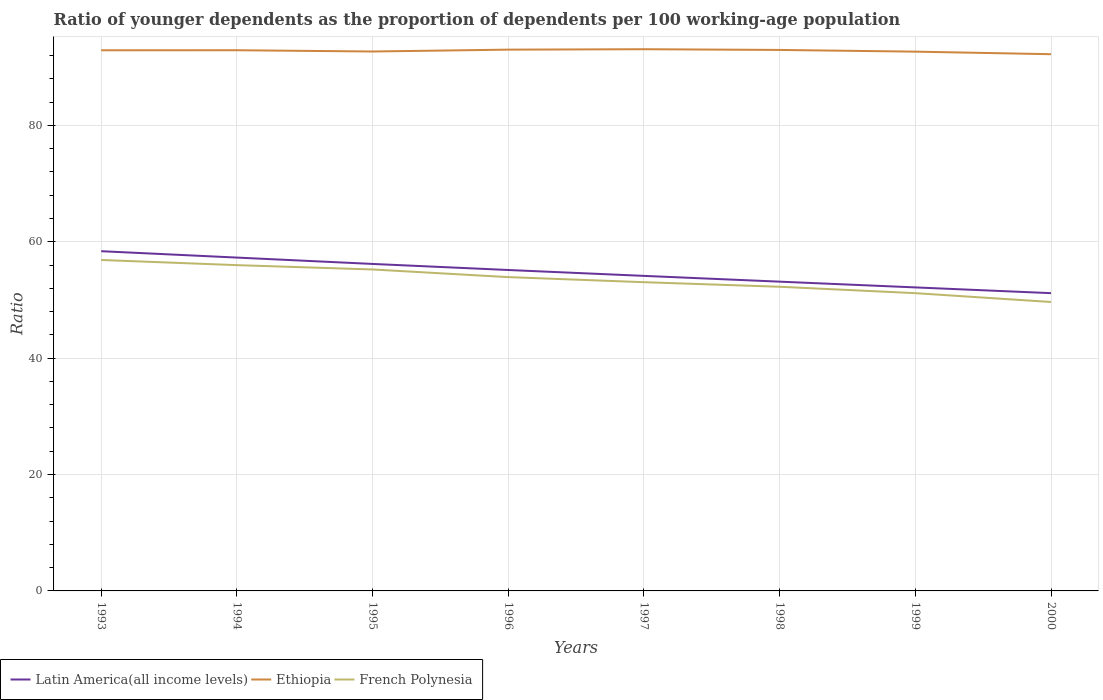Across all years, what is the maximum age dependency ratio(young) in Ethiopia?
Offer a very short reply. 92.23. In which year was the age dependency ratio(young) in French Polynesia maximum?
Provide a succinct answer. 2000. What is the total age dependency ratio(young) in French Polynesia in the graph?
Offer a very short reply. 7.22. What is the difference between the highest and the second highest age dependency ratio(young) in Ethiopia?
Your answer should be compact. 0.86. Are the values on the major ticks of Y-axis written in scientific E-notation?
Provide a succinct answer. No. Does the graph contain any zero values?
Keep it short and to the point. No. Does the graph contain grids?
Make the answer very short. Yes. How many legend labels are there?
Your answer should be compact. 3. How are the legend labels stacked?
Keep it short and to the point. Horizontal. What is the title of the graph?
Ensure brevity in your answer.  Ratio of younger dependents as the proportion of dependents per 100 working-age population. Does "Latvia" appear as one of the legend labels in the graph?
Ensure brevity in your answer.  No. What is the label or title of the X-axis?
Ensure brevity in your answer.  Years. What is the label or title of the Y-axis?
Your answer should be very brief. Ratio. What is the Ratio of Latin America(all income levels) in 1993?
Offer a very short reply. 58.38. What is the Ratio of Ethiopia in 1993?
Your response must be concise. 92.91. What is the Ratio in French Polynesia in 1993?
Provide a short and direct response. 56.87. What is the Ratio in Latin America(all income levels) in 1994?
Your answer should be compact. 57.28. What is the Ratio of Ethiopia in 1994?
Give a very brief answer. 92.92. What is the Ratio in French Polynesia in 1994?
Give a very brief answer. 55.99. What is the Ratio in Latin America(all income levels) in 1995?
Keep it short and to the point. 56.19. What is the Ratio of Ethiopia in 1995?
Make the answer very short. 92.7. What is the Ratio in French Polynesia in 1995?
Offer a terse response. 55.24. What is the Ratio of Latin America(all income levels) in 1996?
Offer a terse response. 55.15. What is the Ratio in Ethiopia in 1996?
Your response must be concise. 93.02. What is the Ratio of French Polynesia in 1996?
Make the answer very short. 53.93. What is the Ratio in Latin America(all income levels) in 1997?
Offer a terse response. 54.14. What is the Ratio in Ethiopia in 1997?
Offer a very short reply. 93.09. What is the Ratio in French Polynesia in 1997?
Your answer should be very brief. 53.06. What is the Ratio in Latin America(all income levels) in 1998?
Your response must be concise. 53.15. What is the Ratio in Ethiopia in 1998?
Your response must be concise. 92.97. What is the Ratio in French Polynesia in 1998?
Your response must be concise. 52.27. What is the Ratio in Latin America(all income levels) in 1999?
Your response must be concise. 52.16. What is the Ratio of Ethiopia in 1999?
Provide a succinct answer. 92.67. What is the Ratio of French Polynesia in 1999?
Your response must be concise. 51.17. What is the Ratio in Latin America(all income levels) in 2000?
Offer a terse response. 51.17. What is the Ratio in Ethiopia in 2000?
Keep it short and to the point. 92.23. What is the Ratio in French Polynesia in 2000?
Give a very brief answer. 49.65. Across all years, what is the maximum Ratio in Latin America(all income levels)?
Your response must be concise. 58.38. Across all years, what is the maximum Ratio in Ethiopia?
Make the answer very short. 93.09. Across all years, what is the maximum Ratio of French Polynesia?
Make the answer very short. 56.87. Across all years, what is the minimum Ratio of Latin America(all income levels)?
Offer a terse response. 51.17. Across all years, what is the minimum Ratio in Ethiopia?
Offer a very short reply. 92.23. Across all years, what is the minimum Ratio of French Polynesia?
Offer a terse response. 49.65. What is the total Ratio in Latin America(all income levels) in the graph?
Make the answer very short. 437.62. What is the total Ratio of Ethiopia in the graph?
Your response must be concise. 742.51. What is the total Ratio in French Polynesia in the graph?
Your response must be concise. 428.17. What is the difference between the Ratio in Latin America(all income levels) in 1993 and that in 1994?
Your answer should be very brief. 1.1. What is the difference between the Ratio of Ethiopia in 1993 and that in 1994?
Offer a very short reply. -0.01. What is the difference between the Ratio in French Polynesia in 1993 and that in 1994?
Your answer should be very brief. 0.89. What is the difference between the Ratio of Latin America(all income levels) in 1993 and that in 1995?
Your answer should be very brief. 2.19. What is the difference between the Ratio in Ethiopia in 1993 and that in 1995?
Ensure brevity in your answer.  0.21. What is the difference between the Ratio in French Polynesia in 1993 and that in 1995?
Make the answer very short. 1.63. What is the difference between the Ratio of Latin America(all income levels) in 1993 and that in 1996?
Provide a short and direct response. 3.23. What is the difference between the Ratio of Ethiopia in 1993 and that in 1996?
Ensure brevity in your answer.  -0.11. What is the difference between the Ratio in French Polynesia in 1993 and that in 1996?
Give a very brief answer. 2.94. What is the difference between the Ratio in Latin America(all income levels) in 1993 and that in 1997?
Keep it short and to the point. 4.24. What is the difference between the Ratio of Ethiopia in 1993 and that in 1997?
Provide a succinct answer. -0.18. What is the difference between the Ratio in French Polynesia in 1993 and that in 1997?
Provide a short and direct response. 3.82. What is the difference between the Ratio of Latin America(all income levels) in 1993 and that in 1998?
Ensure brevity in your answer.  5.23. What is the difference between the Ratio in Ethiopia in 1993 and that in 1998?
Offer a terse response. -0.06. What is the difference between the Ratio of French Polynesia in 1993 and that in 1998?
Make the answer very short. 4.6. What is the difference between the Ratio of Latin America(all income levels) in 1993 and that in 1999?
Keep it short and to the point. 6.22. What is the difference between the Ratio in Ethiopia in 1993 and that in 1999?
Ensure brevity in your answer.  0.23. What is the difference between the Ratio of French Polynesia in 1993 and that in 1999?
Provide a succinct answer. 5.7. What is the difference between the Ratio in Latin America(all income levels) in 1993 and that in 2000?
Give a very brief answer. 7.21. What is the difference between the Ratio of Ethiopia in 1993 and that in 2000?
Give a very brief answer. 0.68. What is the difference between the Ratio in French Polynesia in 1993 and that in 2000?
Provide a short and direct response. 7.22. What is the difference between the Ratio of Latin America(all income levels) in 1994 and that in 1995?
Offer a very short reply. 1.09. What is the difference between the Ratio of Ethiopia in 1994 and that in 1995?
Make the answer very short. 0.22. What is the difference between the Ratio of French Polynesia in 1994 and that in 1995?
Ensure brevity in your answer.  0.74. What is the difference between the Ratio of Latin America(all income levels) in 1994 and that in 1996?
Your response must be concise. 2.13. What is the difference between the Ratio of Ethiopia in 1994 and that in 1996?
Make the answer very short. -0.1. What is the difference between the Ratio of French Polynesia in 1994 and that in 1996?
Ensure brevity in your answer.  2.06. What is the difference between the Ratio of Latin America(all income levels) in 1994 and that in 1997?
Provide a short and direct response. 3.14. What is the difference between the Ratio in Ethiopia in 1994 and that in 1997?
Provide a short and direct response. -0.17. What is the difference between the Ratio of French Polynesia in 1994 and that in 1997?
Ensure brevity in your answer.  2.93. What is the difference between the Ratio of Latin America(all income levels) in 1994 and that in 1998?
Make the answer very short. 4.14. What is the difference between the Ratio of Ethiopia in 1994 and that in 1998?
Offer a very short reply. -0.05. What is the difference between the Ratio in French Polynesia in 1994 and that in 1998?
Keep it short and to the point. 3.72. What is the difference between the Ratio of Latin America(all income levels) in 1994 and that in 1999?
Your answer should be compact. 5.13. What is the difference between the Ratio in Ethiopia in 1994 and that in 1999?
Ensure brevity in your answer.  0.24. What is the difference between the Ratio of French Polynesia in 1994 and that in 1999?
Your answer should be compact. 4.81. What is the difference between the Ratio in Latin America(all income levels) in 1994 and that in 2000?
Your answer should be compact. 6.11. What is the difference between the Ratio of Ethiopia in 1994 and that in 2000?
Your answer should be compact. 0.68. What is the difference between the Ratio in French Polynesia in 1994 and that in 2000?
Your response must be concise. 6.34. What is the difference between the Ratio of Latin America(all income levels) in 1995 and that in 1996?
Ensure brevity in your answer.  1.04. What is the difference between the Ratio in Ethiopia in 1995 and that in 1996?
Make the answer very short. -0.32. What is the difference between the Ratio of French Polynesia in 1995 and that in 1996?
Provide a short and direct response. 1.31. What is the difference between the Ratio in Latin America(all income levels) in 1995 and that in 1997?
Keep it short and to the point. 2.05. What is the difference between the Ratio in Ethiopia in 1995 and that in 1997?
Your response must be concise. -0.39. What is the difference between the Ratio of French Polynesia in 1995 and that in 1997?
Ensure brevity in your answer.  2.19. What is the difference between the Ratio of Latin America(all income levels) in 1995 and that in 1998?
Provide a short and direct response. 3.04. What is the difference between the Ratio of Ethiopia in 1995 and that in 1998?
Ensure brevity in your answer.  -0.27. What is the difference between the Ratio in French Polynesia in 1995 and that in 1998?
Ensure brevity in your answer.  2.97. What is the difference between the Ratio in Latin America(all income levels) in 1995 and that in 1999?
Your response must be concise. 4.03. What is the difference between the Ratio in Ethiopia in 1995 and that in 1999?
Keep it short and to the point. 0.02. What is the difference between the Ratio in French Polynesia in 1995 and that in 1999?
Provide a succinct answer. 4.07. What is the difference between the Ratio of Latin America(all income levels) in 1995 and that in 2000?
Your response must be concise. 5.02. What is the difference between the Ratio of Ethiopia in 1995 and that in 2000?
Provide a short and direct response. 0.46. What is the difference between the Ratio of French Polynesia in 1995 and that in 2000?
Give a very brief answer. 5.59. What is the difference between the Ratio of Latin America(all income levels) in 1996 and that in 1997?
Make the answer very short. 1.01. What is the difference between the Ratio of Ethiopia in 1996 and that in 1997?
Make the answer very short. -0.07. What is the difference between the Ratio of French Polynesia in 1996 and that in 1997?
Offer a terse response. 0.87. What is the difference between the Ratio in Latin America(all income levels) in 1996 and that in 1998?
Offer a terse response. 2. What is the difference between the Ratio of Ethiopia in 1996 and that in 1998?
Offer a terse response. 0.05. What is the difference between the Ratio of French Polynesia in 1996 and that in 1998?
Ensure brevity in your answer.  1.66. What is the difference between the Ratio of Latin America(all income levels) in 1996 and that in 1999?
Your response must be concise. 2.99. What is the difference between the Ratio in Ethiopia in 1996 and that in 1999?
Offer a very short reply. 0.34. What is the difference between the Ratio of French Polynesia in 1996 and that in 1999?
Give a very brief answer. 2.76. What is the difference between the Ratio of Latin America(all income levels) in 1996 and that in 2000?
Provide a short and direct response. 3.98. What is the difference between the Ratio of Ethiopia in 1996 and that in 2000?
Give a very brief answer. 0.78. What is the difference between the Ratio in French Polynesia in 1996 and that in 2000?
Offer a terse response. 4.28. What is the difference between the Ratio of Ethiopia in 1997 and that in 1998?
Your answer should be very brief. 0.12. What is the difference between the Ratio of French Polynesia in 1997 and that in 1998?
Give a very brief answer. 0.79. What is the difference between the Ratio of Latin America(all income levels) in 1997 and that in 1999?
Your response must be concise. 1.98. What is the difference between the Ratio of Ethiopia in 1997 and that in 1999?
Your answer should be very brief. 0.42. What is the difference between the Ratio of French Polynesia in 1997 and that in 1999?
Make the answer very short. 1.88. What is the difference between the Ratio in Latin America(all income levels) in 1997 and that in 2000?
Provide a succinct answer. 2.97. What is the difference between the Ratio in Ethiopia in 1997 and that in 2000?
Give a very brief answer. 0.86. What is the difference between the Ratio of French Polynesia in 1997 and that in 2000?
Offer a terse response. 3.41. What is the difference between the Ratio of Ethiopia in 1998 and that in 1999?
Provide a short and direct response. 0.29. What is the difference between the Ratio of French Polynesia in 1998 and that in 1999?
Make the answer very short. 1.1. What is the difference between the Ratio in Latin America(all income levels) in 1998 and that in 2000?
Ensure brevity in your answer.  1.98. What is the difference between the Ratio in Ethiopia in 1998 and that in 2000?
Give a very brief answer. 0.73. What is the difference between the Ratio of French Polynesia in 1998 and that in 2000?
Your answer should be compact. 2.62. What is the difference between the Ratio of Latin America(all income levels) in 1999 and that in 2000?
Ensure brevity in your answer.  0.99. What is the difference between the Ratio in Ethiopia in 1999 and that in 2000?
Offer a terse response. 0.44. What is the difference between the Ratio in French Polynesia in 1999 and that in 2000?
Your answer should be very brief. 1.52. What is the difference between the Ratio in Latin America(all income levels) in 1993 and the Ratio in Ethiopia in 1994?
Offer a very short reply. -34.54. What is the difference between the Ratio in Latin America(all income levels) in 1993 and the Ratio in French Polynesia in 1994?
Give a very brief answer. 2.4. What is the difference between the Ratio in Ethiopia in 1993 and the Ratio in French Polynesia in 1994?
Your response must be concise. 36.92. What is the difference between the Ratio of Latin America(all income levels) in 1993 and the Ratio of Ethiopia in 1995?
Give a very brief answer. -34.32. What is the difference between the Ratio of Latin America(all income levels) in 1993 and the Ratio of French Polynesia in 1995?
Your response must be concise. 3.14. What is the difference between the Ratio in Ethiopia in 1993 and the Ratio in French Polynesia in 1995?
Keep it short and to the point. 37.67. What is the difference between the Ratio in Latin America(all income levels) in 1993 and the Ratio in Ethiopia in 1996?
Give a very brief answer. -34.64. What is the difference between the Ratio of Latin America(all income levels) in 1993 and the Ratio of French Polynesia in 1996?
Offer a very short reply. 4.45. What is the difference between the Ratio in Ethiopia in 1993 and the Ratio in French Polynesia in 1996?
Provide a short and direct response. 38.98. What is the difference between the Ratio of Latin America(all income levels) in 1993 and the Ratio of Ethiopia in 1997?
Your answer should be very brief. -34.71. What is the difference between the Ratio of Latin America(all income levels) in 1993 and the Ratio of French Polynesia in 1997?
Ensure brevity in your answer.  5.33. What is the difference between the Ratio in Ethiopia in 1993 and the Ratio in French Polynesia in 1997?
Your response must be concise. 39.85. What is the difference between the Ratio in Latin America(all income levels) in 1993 and the Ratio in Ethiopia in 1998?
Your answer should be very brief. -34.59. What is the difference between the Ratio of Latin America(all income levels) in 1993 and the Ratio of French Polynesia in 1998?
Provide a succinct answer. 6.11. What is the difference between the Ratio in Ethiopia in 1993 and the Ratio in French Polynesia in 1998?
Offer a terse response. 40.64. What is the difference between the Ratio of Latin America(all income levels) in 1993 and the Ratio of Ethiopia in 1999?
Your answer should be compact. -34.29. What is the difference between the Ratio in Latin America(all income levels) in 1993 and the Ratio in French Polynesia in 1999?
Your answer should be compact. 7.21. What is the difference between the Ratio of Ethiopia in 1993 and the Ratio of French Polynesia in 1999?
Offer a very short reply. 41.74. What is the difference between the Ratio in Latin America(all income levels) in 1993 and the Ratio in Ethiopia in 2000?
Your answer should be very brief. -33.85. What is the difference between the Ratio in Latin America(all income levels) in 1993 and the Ratio in French Polynesia in 2000?
Your answer should be compact. 8.73. What is the difference between the Ratio in Ethiopia in 1993 and the Ratio in French Polynesia in 2000?
Offer a terse response. 43.26. What is the difference between the Ratio of Latin America(all income levels) in 1994 and the Ratio of Ethiopia in 1995?
Make the answer very short. -35.41. What is the difference between the Ratio of Latin America(all income levels) in 1994 and the Ratio of French Polynesia in 1995?
Your answer should be compact. 2.04. What is the difference between the Ratio in Ethiopia in 1994 and the Ratio in French Polynesia in 1995?
Provide a short and direct response. 37.68. What is the difference between the Ratio in Latin America(all income levels) in 1994 and the Ratio in Ethiopia in 1996?
Ensure brevity in your answer.  -35.73. What is the difference between the Ratio in Latin America(all income levels) in 1994 and the Ratio in French Polynesia in 1996?
Provide a short and direct response. 3.36. What is the difference between the Ratio of Ethiopia in 1994 and the Ratio of French Polynesia in 1996?
Give a very brief answer. 38.99. What is the difference between the Ratio of Latin America(all income levels) in 1994 and the Ratio of Ethiopia in 1997?
Make the answer very short. -35.81. What is the difference between the Ratio in Latin America(all income levels) in 1994 and the Ratio in French Polynesia in 1997?
Offer a terse response. 4.23. What is the difference between the Ratio of Ethiopia in 1994 and the Ratio of French Polynesia in 1997?
Make the answer very short. 39.86. What is the difference between the Ratio in Latin America(all income levels) in 1994 and the Ratio in Ethiopia in 1998?
Ensure brevity in your answer.  -35.68. What is the difference between the Ratio in Latin America(all income levels) in 1994 and the Ratio in French Polynesia in 1998?
Your answer should be very brief. 5.02. What is the difference between the Ratio in Ethiopia in 1994 and the Ratio in French Polynesia in 1998?
Your response must be concise. 40.65. What is the difference between the Ratio in Latin America(all income levels) in 1994 and the Ratio in Ethiopia in 1999?
Make the answer very short. -35.39. What is the difference between the Ratio of Latin America(all income levels) in 1994 and the Ratio of French Polynesia in 1999?
Provide a succinct answer. 6.11. What is the difference between the Ratio in Ethiopia in 1994 and the Ratio in French Polynesia in 1999?
Your answer should be very brief. 41.75. What is the difference between the Ratio in Latin America(all income levels) in 1994 and the Ratio in Ethiopia in 2000?
Your answer should be very brief. -34.95. What is the difference between the Ratio of Latin America(all income levels) in 1994 and the Ratio of French Polynesia in 2000?
Provide a short and direct response. 7.63. What is the difference between the Ratio of Ethiopia in 1994 and the Ratio of French Polynesia in 2000?
Provide a succinct answer. 43.27. What is the difference between the Ratio of Latin America(all income levels) in 1995 and the Ratio of Ethiopia in 1996?
Ensure brevity in your answer.  -36.83. What is the difference between the Ratio of Latin America(all income levels) in 1995 and the Ratio of French Polynesia in 1996?
Offer a very short reply. 2.26. What is the difference between the Ratio in Ethiopia in 1995 and the Ratio in French Polynesia in 1996?
Give a very brief answer. 38.77. What is the difference between the Ratio in Latin America(all income levels) in 1995 and the Ratio in Ethiopia in 1997?
Provide a short and direct response. -36.9. What is the difference between the Ratio in Latin America(all income levels) in 1995 and the Ratio in French Polynesia in 1997?
Your response must be concise. 3.14. What is the difference between the Ratio of Ethiopia in 1995 and the Ratio of French Polynesia in 1997?
Provide a succinct answer. 39.64. What is the difference between the Ratio of Latin America(all income levels) in 1995 and the Ratio of Ethiopia in 1998?
Ensure brevity in your answer.  -36.78. What is the difference between the Ratio of Latin America(all income levels) in 1995 and the Ratio of French Polynesia in 1998?
Make the answer very short. 3.92. What is the difference between the Ratio in Ethiopia in 1995 and the Ratio in French Polynesia in 1998?
Your answer should be very brief. 40.43. What is the difference between the Ratio in Latin America(all income levels) in 1995 and the Ratio in Ethiopia in 1999?
Your answer should be very brief. -36.48. What is the difference between the Ratio in Latin America(all income levels) in 1995 and the Ratio in French Polynesia in 1999?
Provide a short and direct response. 5.02. What is the difference between the Ratio in Ethiopia in 1995 and the Ratio in French Polynesia in 1999?
Give a very brief answer. 41.53. What is the difference between the Ratio of Latin America(all income levels) in 1995 and the Ratio of Ethiopia in 2000?
Ensure brevity in your answer.  -36.04. What is the difference between the Ratio in Latin America(all income levels) in 1995 and the Ratio in French Polynesia in 2000?
Give a very brief answer. 6.54. What is the difference between the Ratio of Ethiopia in 1995 and the Ratio of French Polynesia in 2000?
Provide a short and direct response. 43.05. What is the difference between the Ratio in Latin America(all income levels) in 1996 and the Ratio in Ethiopia in 1997?
Make the answer very short. -37.94. What is the difference between the Ratio in Latin America(all income levels) in 1996 and the Ratio in French Polynesia in 1997?
Make the answer very short. 2.09. What is the difference between the Ratio of Ethiopia in 1996 and the Ratio of French Polynesia in 1997?
Your response must be concise. 39.96. What is the difference between the Ratio of Latin America(all income levels) in 1996 and the Ratio of Ethiopia in 1998?
Provide a succinct answer. -37.82. What is the difference between the Ratio in Latin America(all income levels) in 1996 and the Ratio in French Polynesia in 1998?
Keep it short and to the point. 2.88. What is the difference between the Ratio in Ethiopia in 1996 and the Ratio in French Polynesia in 1998?
Provide a succinct answer. 40.75. What is the difference between the Ratio in Latin America(all income levels) in 1996 and the Ratio in Ethiopia in 1999?
Ensure brevity in your answer.  -37.53. What is the difference between the Ratio of Latin America(all income levels) in 1996 and the Ratio of French Polynesia in 1999?
Offer a terse response. 3.98. What is the difference between the Ratio of Ethiopia in 1996 and the Ratio of French Polynesia in 1999?
Provide a succinct answer. 41.85. What is the difference between the Ratio of Latin America(all income levels) in 1996 and the Ratio of Ethiopia in 2000?
Your answer should be very brief. -37.08. What is the difference between the Ratio of Latin America(all income levels) in 1996 and the Ratio of French Polynesia in 2000?
Your answer should be compact. 5.5. What is the difference between the Ratio of Ethiopia in 1996 and the Ratio of French Polynesia in 2000?
Your answer should be very brief. 43.37. What is the difference between the Ratio in Latin America(all income levels) in 1997 and the Ratio in Ethiopia in 1998?
Keep it short and to the point. -38.83. What is the difference between the Ratio in Latin America(all income levels) in 1997 and the Ratio in French Polynesia in 1998?
Keep it short and to the point. 1.87. What is the difference between the Ratio in Ethiopia in 1997 and the Ratio in French Polynesia in 1998?
Ensure brevity in your answer.  40.82. What is the difference between the Ratio in Latin America(all income levels) in 1997 and the Ratio in Ethiopia in 1999?
Give a very brief answer. -38.54. What is the difference between the Ratio of Latin America(all income levels) in 1997 and the Ratio of French Polynesia in 1999?
Keep it short and to the point. 2.97. What is the difference between the Ratio of Ethiopia in 1997 and the Ratio of French Polynesia in 1999?
Provide a succinct answer. 41.92. What is the difference between the Ratio in Latin America(all income levels) in 1997 and the Ratio in Ethiopia in 2000?
Keep it short and to the point. -38.09. What is the difference between the Ratio in Latin America(all income levels) in 1997 and the Ratio in French Polynesia in 2000?
Provide a short and direct response. 4.49. What is the difference between the Ratio in Ethiopia in 1997 and the Ratio in French Polynesia in 2000?
Provide a succinct answer. 43.44. What is the difference between the Ratio in Latin America(all income levels) in 1998 and the Ratio in Ethiopia in 1999?
Your answer should be very brief. -39.53. What is the difference between the Ratio of Latin America(all income levels) in 1998 and the Ratio of French Polynesia in 1999?
Give a very brief answer. 1.98. What is the difference between the Ratio of Ethiopia in 1998 and the Ratio of French Polynesia in 1999?
Your response must be concise. 41.8. What is the difference between the Ratio of Latin America(all income levels) in 1998 and the Ratio of Ethiopia in 2000?
Ensure brevity in your answer.  -39.09. What is the difference between the Ratio of Latin America(all income levels) in 1998 and the Ratio of French Polynesia in 2000?
Your answer should be compact. 3.5. What is the difference between the Ratio of Ethiopia in 1998 and the Ratio of French Polynesia in 2000?
Offer a terse response. 43.32. What is the difference between the Ratio of Latin America(all income levels) in 1999 and the Ratio of Ethiopia in 2000?
Make the answer very short. -40.07. What is the difference between the Ratio of Latin America(all income levels) in 1999 and the Ratio of French Polynesia in 2000?
Keep it short and to the point. 2.51. What is the difference between the Ratio in Ethiopia in 1999 and the Ratio in French Polynesia in 2000?
Provide a succinct answer. 43.02. What is the average Ratio of Latin America(all income levels) per year?
Give a very brief answer. 54.7. What is the average Ratio of Ethiopia per year?
Your answer should be compact. 92.81. What is the average Ratio of French Polynesia per year?
Offer a terse response. 53.52. In the year 1993, what is the difference between the Ratio in Latin America(all income levels) and Ratio in Ethiopia?
Provide a succinct answer. -34.53. In the year 1993, what is the difference between the Ratio in Latin America(all income levels) and Ratio in French Polynesia?
Your answer should be very brief. 1.51. In the year 1993, what is the difference between the Ratio in Ethiopia and Ratio in French Polynesia?
Provide a short and direct response. 36.04. In the year 1994, what is the difference between the Ratio in Latin America(all income levels) and Ratio in Ethiopia?
Offer a terse response. -35.63. In the year 1994, what is the difference between the Ratio in Latin America(all income levels) and Ratio in French Polynesia?
Offer a terse response. 1.3. In the year 1994, what is the difference between the Ratio of Ethiopia and Ratio of French Polynesia?
Ensure brevity in your answer.  36.93. In the year 1995, what is the difference between the Ratio in Latin America(all income levels) and Ratio in Ethiopia?
Your answer should be compact. -36.51. In the year 1995, what is the difference between the Ratio of Latin America(all income levels) and Ratio of French Polynesia?
Provide a short and direct response. 0.95. In the year 1995, what is the difference between the Ratio in Ethiopia and Ratio in French Polynesia?
Offer a very short reply. 37.46. In the year 1996, what is the difference between the Ratio in Latin America(all income levels) and Ratio in Ethiopia?
Ensure brevity in your answer.  -37.87. In the year 1996, what is the difference between the Ratio of Latin America(all income levels) and Ratio of French Polynesia?
Keep it short and to the point. 1.22. In the year 1996, what is the difference between the Ratio in Ethiopia and Ratio in French Polynesia?
Your answer should be compact. 39.09. In the year 1997, what is the difference between the Ratio in Latin America(all income levels) and Ratio in Ethiopia?
Make the answer very short. -38.95. In the year 1997, what is the difference between the Ratio in Latin America(all income levels) and Ratio in French Polynesia?
Give a very brief answer. 1.08. In the year 1997, what is the difference between the Ratio of Ethiopia and Ratio of French Polynesia?
Provide a short and direct response. 40.04. In the year 1998, what is the difference between the Ratio of Latin America(all income levels) and Ratio of Ethiopia?
Your response must be concise. -39.82. In the year 1998, what is the difference between the Ratio in Latin America(all income levels) and Ratio in French Polynesia?
Offer a very short reply. 0.88. In the year 1998, what is the difference between the Ratio in Ethiopia and Ratio in French Polynesia?
Your answer should be very brief. 40.7. In the year 1999, what is the difference between the Ratio in Latin America(all income levels) and Ratio in Ethiopia?
Your response must be concise. -40.52. In the year 1999, what is the difference between the Ratio of Latin America(all income levels) and Ratio of French Polynesia?
Offer a very short reply. 0.99. In the year 1999, what is the difference between the Ratio in Ethiopia and Ratio in French Polynesia?
Keep it short and to the point. 41.5. In the year 2000, what is the difference between the Ratio of Latin America(all income levels) and Ratio of Ethiopia?
Your answer should be compact. -41.06. In the year 2000, what is the difference between the Ratio of Latin America(all income levels) and Ratio of French Polynesia?
Provide a succinct answer. 1.52. In the year 2000, what is the difference between the Ratio of Ethiopia and Ratio of French Polynesia?
Offer a terse response. 42.58. What is the ratio of the Ratio of Latin America(all income levels) in 1993 to that in 1994?
Your answer should be compact. 1.02. What is the ratio of the Ratio of Ethiopia in 1993 to that in 1994?
Keep it short and to the point. 1. What is the ratio of the Ratio of French Polynesia in 1993 to that in 1994?
Your answer should be compact. 1.02. What is the ratio of the Ratio of Latin America(all income levels) in 1993 to that in 1995?
Offer a terse response. 1.04. What is the ratio of the Ratio in French Polynesia in 1993 to that in 1995?
Your response must be concise. 1.03. What is the ratio of the Ratio in Latin America(all income levels) in 1993 to that in 1996?
Your response must be concise. 1.06. What is the ratio of the Ratio in French Polynesia in 1993 to that in 1996?
Provide a succinct answer. 1.05. What is the ratio of the Ratio in Latin America(all income levels) in 1993 to that in 1997?
Give a very brief answer. 1.08. What is the ratio of the Ratio of French Polynesia in 1993 to that in 1997?
Provide a short and direct response. 1.07. What is the ratio of the Ratio in Latin America(all income levels) in 1993 to that in 1998?
Offer a very short reply. 1.1. What is the ratio of the Ratio of Ethiopia in 1993 to that in 1998?
Provide a short and direct response. 1. What is the ratio of the Ratio in French Polynesia in 1993 to that in 1998?
Ensure brevity in your answer.  1.09. What is the ratio of the Ratio of Latin America(all income levels) in 1993 to that in 1999?
Your answer should be compact. 1.12. What is the ratio of the Ratio in French Polynesia in 1993 to that in 1999?
Offer a terse response. 1.11. What is the ratio of the Ratio in Latin America(all income levels) in 1993 to that in 2000?
Provide a short and direct response. 1.14. What is the ratio of the Ratio in Ethiopia in 1993 to that in 2000?
Your answer should be very brief. 1.01. What is the ratio of the Ratio in French Polynesia in 1993 to that in 2000?
Your answer should be very brief. 1.15. What is the ratio of the Ratio of Latin America(all income levels) in 1994 to that in 1995?
Your answer should be very brief. 1.02. What is the ratio of the Ratio in Ethiopia in 1994 to that in 1995?
Your answer should be very brief. 1. What is the ratio of the Ratio of French Polynesia in 1994 to that in 1995?
Your answer should be very brief. 1.01. What is the ratio of the Ratio of Latin America(all income levels) in 1994 to that in 1996?
Offer a very short reply. 1.04. What is the ratio of the Ratio of Ethiopia in 1994 to that in 1996?
Provide a short and direct response. 1. What is the ratio of the Ratio of French Polynesia in 1994 to that in 1996?
Give a very brief answer. 1.04. What is the ratio of the Ratio in Latin America(all income levels) in 1994 to that in 1997?
Ensure brevity in your answer.  1.06. What is the ratio of the Ratio in French Polynesia in 1994 to that in 1997?
Provide a short and direct response. 1.06. What is the ratio of the Ratio in Latin America(all income levels) in 1994 to that in 1998?
Your answer should be very brief. 1.08. What is the ratio of the Ratio of Ethiopia in 1994 to that in 1998?
Provide a short and direct response. 1. What is the ratio of the Ratio in French Polynesia in 1994 to that in 1998?
Keep it short and to the point. 1.07. What is the ratio of the Ratio of Latin America(all income levels) in 1994 to that in 1999?
Your answer should be compact. 1.1. What is the ratio of the Ratio of Ethiopia in 1994 to that in 1999?
Ensure brevity in your answer.  1. What is the ratio of the Ratio of French Polynesia in 1994 to that in 1999?
Keep it short and to the point. 1.09. What is the ratio of the Ratio in Latin America(all income levels) in 1994 to that in 2000?
Provide a succinct answer. 1.12. What is the ratio of the Ratio of Ethiopia in 1994 to that in 2000?
Keep it short and to the point. 1.01. What is the ratio of the Ratio in French Polynesia in 1994 to that in 2000?
Offer a very short reply. 1.13. What is the ratio of the Ratio in Latin America(all income levels) in 1995 to that in 1996?
Your answer should be compact. 1.02. What is the ratio of the Ratio in Ethiopia in 1995 to that in 1996?
Keep it short and to the point. 1. What is the ratio of the Ratio in French Polynesia in 1995 to that in 1996?
Offer a terse response. 1.02. What is the ratio of the Ratio in Latin America(all income levels) in 1995 to that in 1997?
Your answer should be compact. 1.04. What is the ratio of the Ratio of French Polynesia in 1995 to that in 1997?
Keep it short and to the point. 1.04. What is the ratio of the Ratio in Latin America(all income levels) in 1995 to that in 1998?
Your answer should be very brief. 1.06. What is the ratio of the Ratio of French Polynesia in 1995 to that in 1998?
Make the answer very short. 1.06. What is the ratio of the Ratio in Latin America(all income levels) in 1995 to that in 1999?
Provide a short and direct response. 1.08. What is the ratio of the Ratio in Ethiopia in 1995 to that in 1999?
Your answer should be very brief. 1. What is the ratio of the Ratio in French Polynesia in 1995 to that in 1999?
Your response must be concise. 1.08. What is the ratio of the Ratio in Latin America(all income levels) in 1995 to that in 2000?
Offer a terse response. 1.1. What is the ratio of the Ratio of French Polynesia in 1995 to that in 2000?
Offer a terse response. 1.11. What is the ratio of the Ratio of Latin America(all income levels) in 1996 to that in 1997?
Ensure brevity in your answer.  1.02. What is the ratio of the Ratio in Ethiopia in 1996 to that in 1997?
Make the answer very short. 1. What is the ratio of the Ratio of French Polynesia in 1996 to that in 1997?
Ensure brevity in your answer.  1.02. What is the ratio of the Ratio in Latin America(all income levels) in 1996 to that in 1998?
Make the answer very short. 1.04. What is the ratio of the Ratio of Ethiopia in 1996 to that in 1998?
Your answer should be very brief. 1. What is the ratio of the Ratio in French Polynesia in 1996 to that in 1998?
Provide a succinct answer. 1.03. What is the ratio of the Ratio of Latin America(all income levels) in 1996 to that in 1999?
Offer a very short reply. 1.06. What is the ratio of the Ratio in Ethiopia in 1996 to that in 1999?
Offer a terse response. 1. What is the ratio of the Ratio of French Polynesia in 1996 to that in 1999?
Offer a terse response. 1.05. What is the ratio of the Ratio in Latin America(all income levels) in 1996 to that in 2000?
Offer a very short reply. 1.08. What is the ratio of the Ratio in Ethiopia in 1996 to that in 2000?
Keep it short and to the point. 1.01. What is the ratio of the Ratio of French Polynesia in 1996 to that in 2000?
Offer a very short reply. 1.09. What is the ratio of the Ratio of Latin America(all income levels) in 1997 to that in 1998?
Make the answer very short. 1.02. What is the ratio of the Ratio of French Polynesia in 1997 to that in 1998?
Your answer should be very brief. 1.02. What is the ratio of the Ratio of Latin America(all income levels) in 1997 to that in 1999?
Your answer should be very brief. 1.04. What is the ratio of the Ratio in Ethiopia in 1997 to that in 1999?
Your answer should be compact. 1. What is the ratio of the Ratio of French Polynesia in 1997 to that in 1999?
Make the answer very short. 1.04. What is the ratio of the Ratio of Latin America(all income levels) in 1997 to that in 2000?
Ensure brevity in your answer.  1.06. What is the ratio of the Ratio of Ethiopia in 1997 to that in 2000?
Offer a terse response. 1.01. What is the ratio of the Ratio in French Polynesia in 1997 to that in 2000?
Keep it short and to the point. 1.07. What is the ratio of the Ratio in Latin America(all income levels) in 1998 to that in 1999?
Ensure brevity in your answer.  1.02. What is the ratio of the Ratio of Ethiopia in 1998 to that in 1999?
Your answer should be very brief. 1. What is the ratio of the Ratio of French Polynesia in 1998 to that in 1999?
Give a very brief answer. 1.02. What is the ratio of the Ratio of Latin America(all income levels) in 1998 to that in 2000?
Keep it short and to the point. 1.04. What is the ratio of the Ratio in French Polynesia in 1998 to that in 2000?
Provide a short and direct response. 1.05. What is the ratio of the Ratio of Latin America(all income levels) in 1999 to that in 2000?
Offer a terse response. 1.02. What is the ratio of the Ratio of Ethiopia in 1999 to that in 2000?
Ensure brevity in your answer.  1. What is the ratio of the Ratio of French Polynesia in 1999 to that in 2000?
Give a very brief answer. 1.03. What is the difference between the highest and the second highest Ratio in Latin America(all income levels)?
Offer a terse response. 1.1. What is the difference between the highest and the second highest Ratio in Ethiopia?
Your answer should be very brief. 0.07. What is the difference between the highest and the second highest Ratio of French Polynesia?
Your answer should be very brief. 0.89. What is the difference between the highest and the lowest Ratio in Latin America(all income levels)?
Offer a terse response. 7.21. What is the difference between the highest and the lowest Ratio in Ethiopia?
Your answer should be compact. 0.86. What is the difference between the highest and the lowest Ratio in French Polynesia?
Provide a succinct answer. 7.22. 